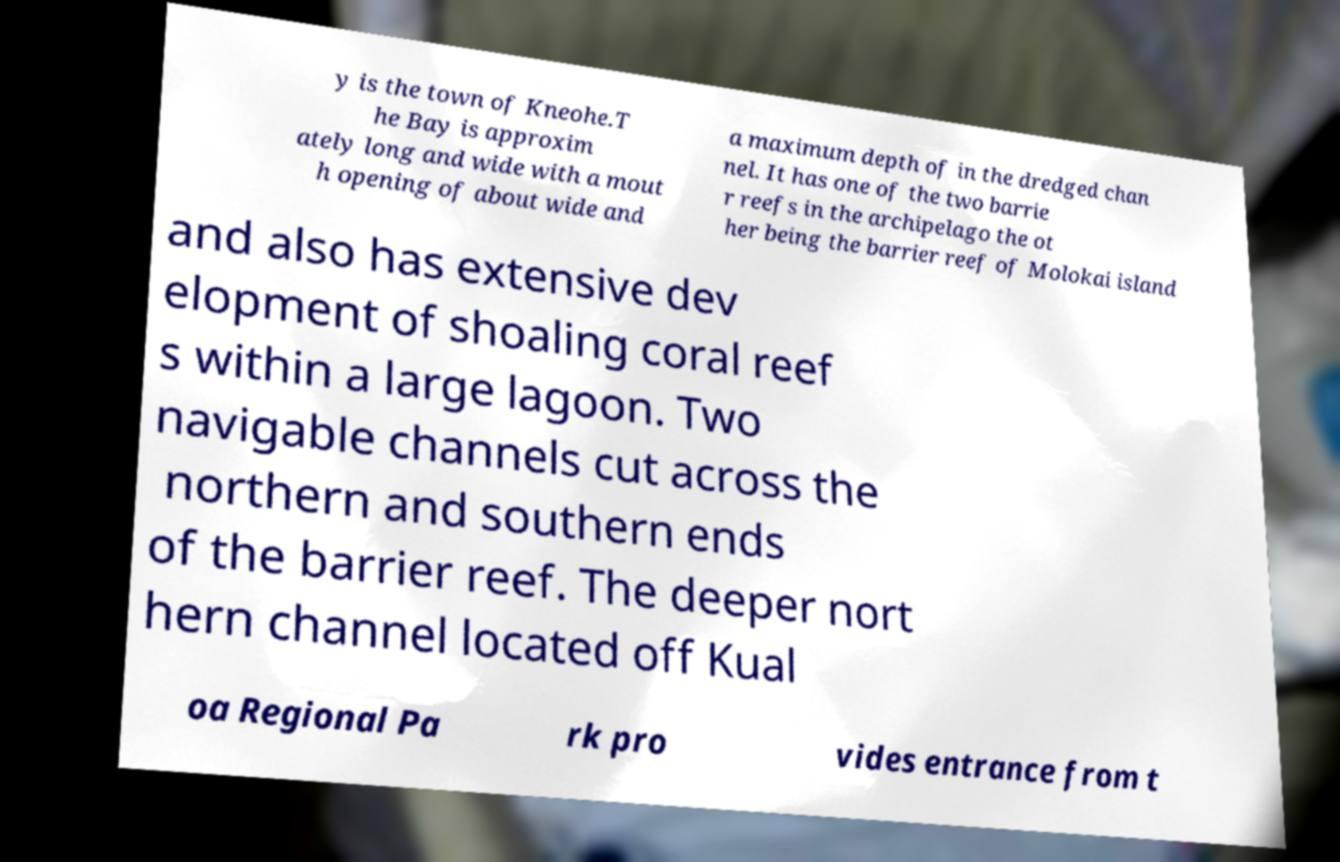There's text embedded in this image that I need extracted. Can you transcribe it verbatim? y is the town of Kneohe.T he Bay is approxim ately long and wide with a mout h opening of about wide and a maximum depth of in the dredged chan nel. It has one of the two barrie r reefs in the archipelago the ot her being the barrier reef of Molokai island and also has extensive dev elopment of shoaling coral reef s within a large lagoon. Two navigable channels cut across the northern and southern ends of the barrier reef. The deeper nort hern channel located off Kual oa Regional Pa rk pro vides entrance from t 